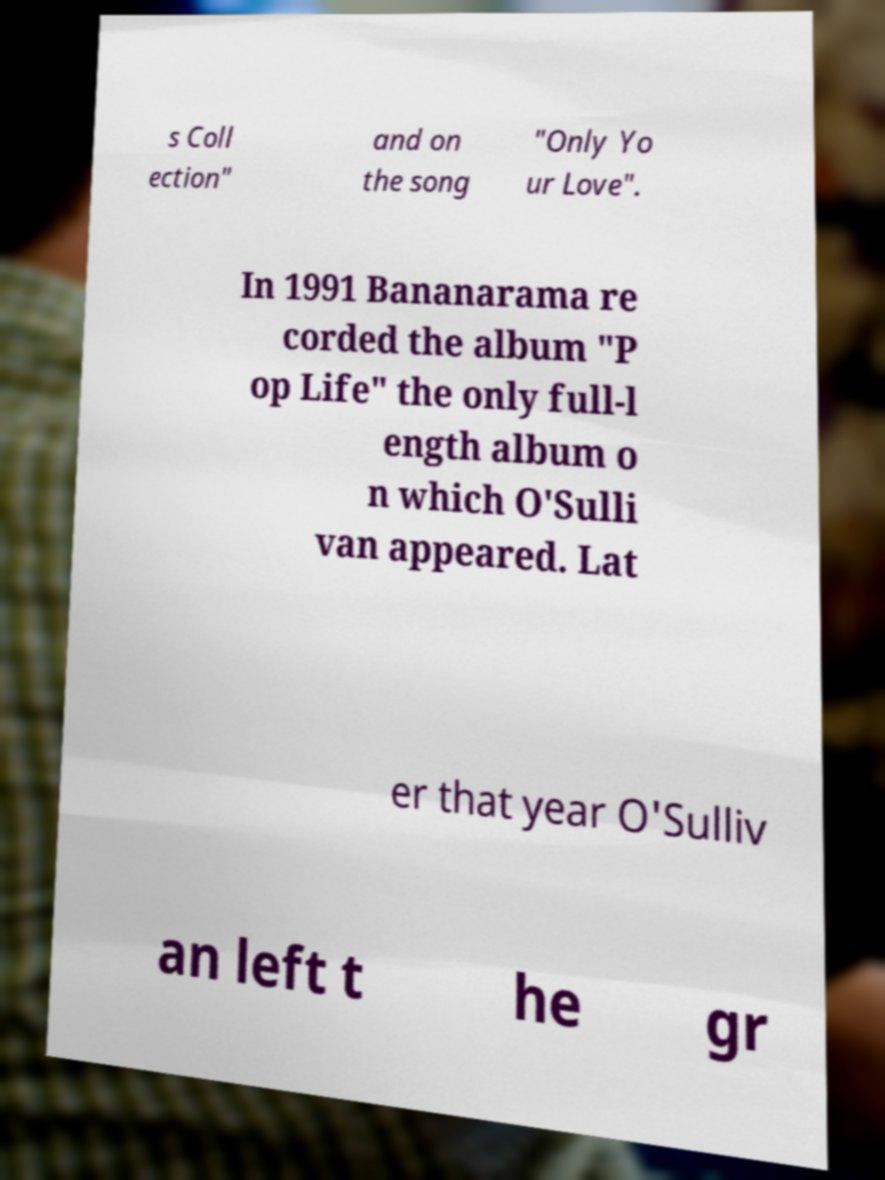Please identify and transcribe the text found in this image. s Coll ection" and on the song "Only Yo ur Love". In 1991 Bananarama re corded the album "P op Life" the only full-l ength album o n which O'Sulli van appeared. Lat er that year O'Sulliv an left t he gr 